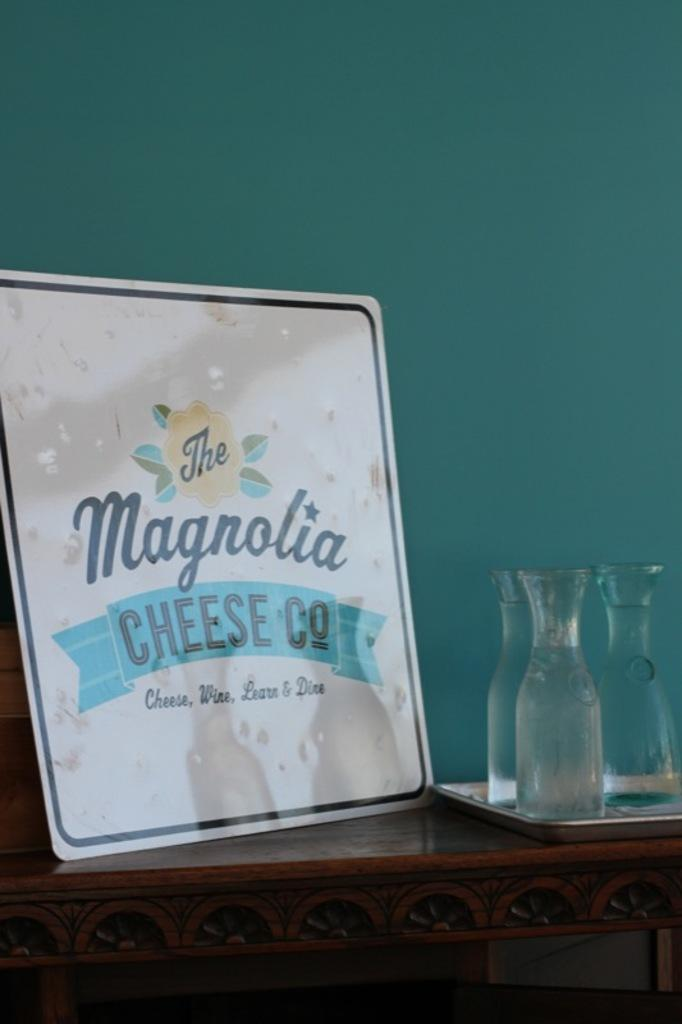What type of furniture is present in the image? There is a table in the image. What is placed on the table? There is a board with text and glasses on the table. How many planes are flying over the table in the image? There are no planes visible in the image; it only features a table with a board and glasses. 